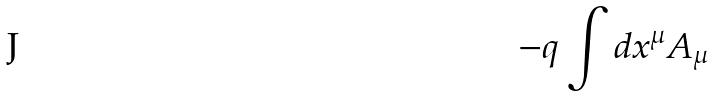<formula> <loc_0><loc_0><loc_500><loc_500>- q \int d x ^ { \mu } A _ { \mu }</formula> 